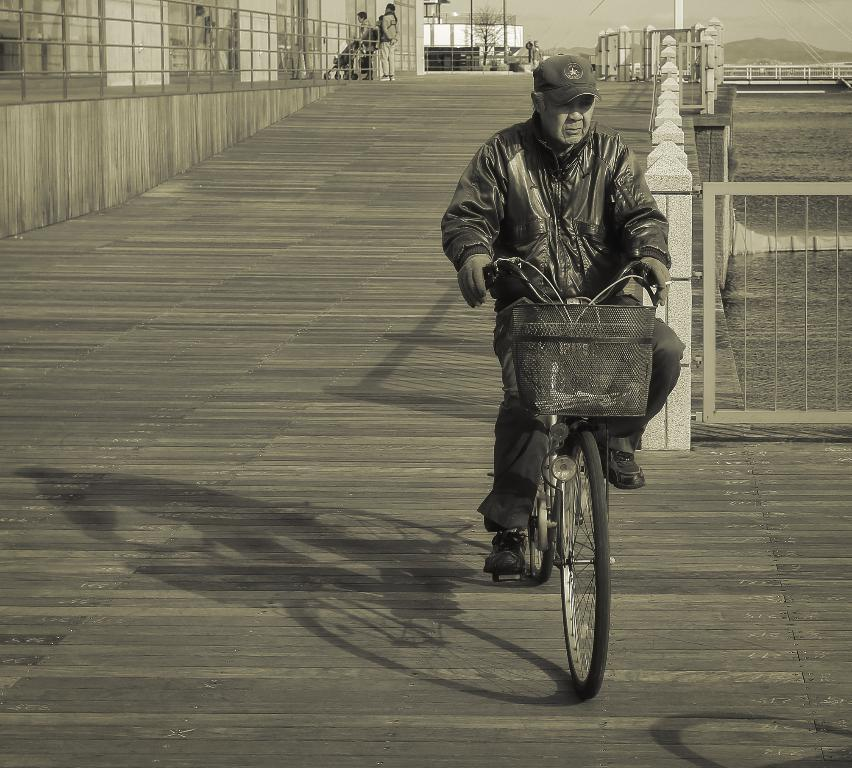What is the man in the image doing? The man is riding a bicycle in the image. Where is the man riding the bicycle? The man is on the road. What can be seen in the background of the image? There is fencing in the image. Can you describe the man's position on the bicycle? The man is sitting on the bike. What is visible at the top of the image? The sky is visible in the image. What type of powder is being used by the man to clean his tooth in the image? There is no mention of powder or tooth cleaning in the image; the man is simply riding a bicycle. 